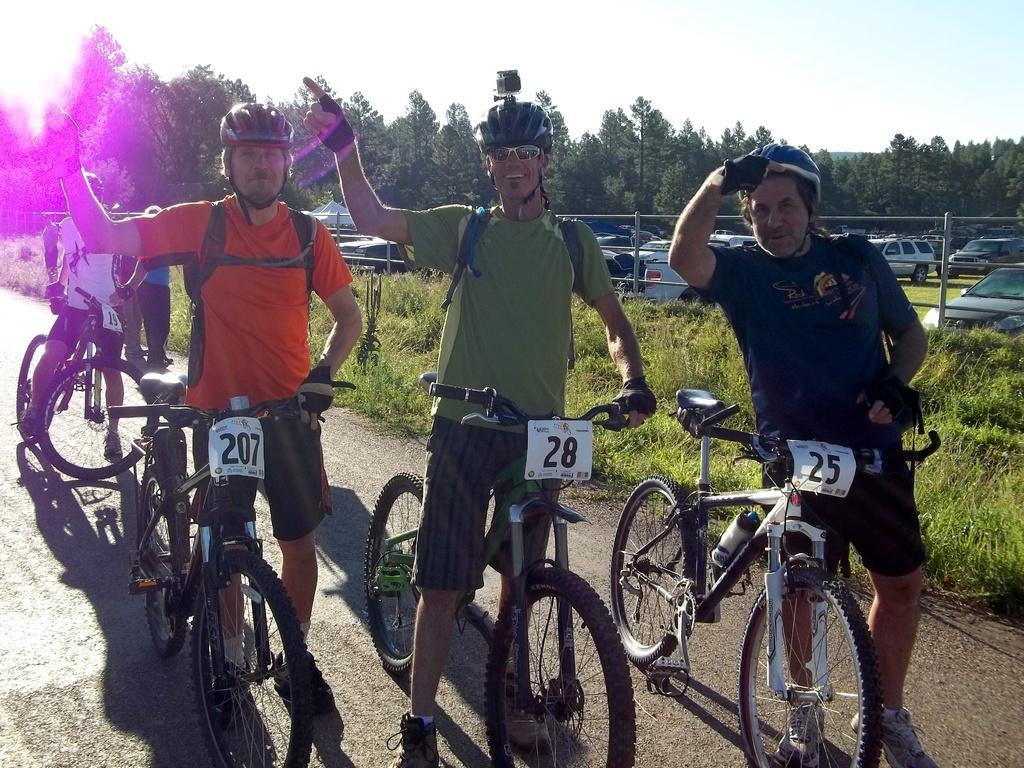Could you give a brief overview of what you see in this image? In this image I can see people among them some are sitting on bicycle and some are standing on the road and holding bicycles. These people are wearing helmets. In the background I can see grass fence and vehicles on the ground. In the background I can see trees and the sky. 